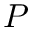<formula> <loc_0><loc_0><loc_500><loc_500>P</formula> 